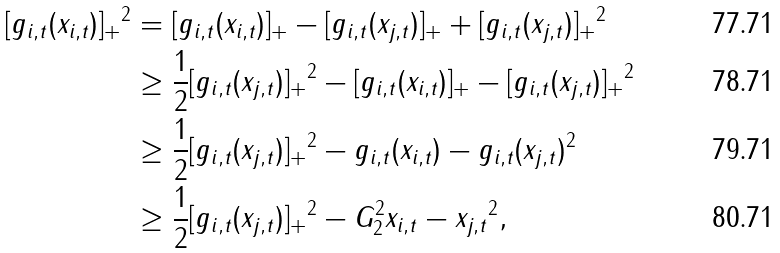<formula> <loc_0><loc_0><loc_500><loc_500>\| [ g _ { i , t } ( x _ { i , t } ) ] _ { + } \| ^ { 2 } & = \| [ g _ { i , t } ( x _ { i , t } ) ] _ { + } - [ g _ { i , t } ( x _ { j , t } ) ] _ { + } + [ g _ { i , t } ( x _ { j , t } ) ] _ { + } \| ^ { 2 } \\ & \geq \frac { 1 } { 2 } \| [ g _ { i , t } ( x _ { j , t } ) ] _ { + } \| ^ { 2 } - \| [ g _ { i , t } ( x _ { i , t } ) ] _ { + } - [ g _ { i , t } ( x _ { j , t } ) ] _ { + } \| ^ { 2 } \\ & \geq \frac { 1 } { 2 } \| [ g _ { i , t } ( x _ { j , t } ) ] _ { + } \| ^ { 2 } - \| g _ { i , t } ( x _ { i , t } ) - g _ { i , t } ( x _ { j , t } ) \| ^ { 2 } \\ & \geq \frac { 1 } { 2 } \| [ g _ { i , t } ( x _ { j , t } ) ] _ { + } \| ^ { 2 } - G _ { 2 } ^ { 2 } \| x _ { i , t } - x _ { j , t } \| ^ { 2 } ,</formula> 